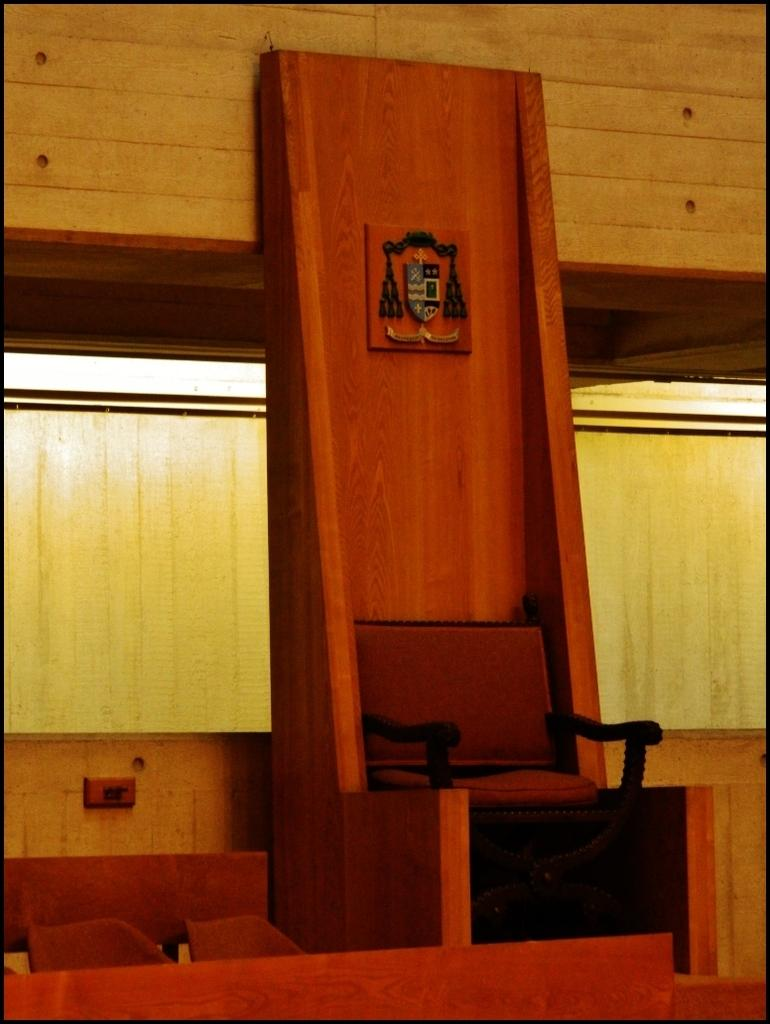What type of furniture is present in the image? There is a chair in the image. What is the chair placed on? The chair is on a wooden stand. What can be seen in the background of the image? There is a wooden wall in the background of the image. Are there any other chairs visible in the image? Yes, another chair is visible on the left side of the image. What type of wax is being used to create the chairs in the image? There is no mention of wax or any wax-related activity in the image. The chairs are made of wood, as indicated by the wooden stand and wooden wall. 